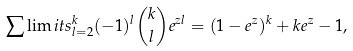<formula> <loc_0><loc_0><loc_500><loc_500>\sum \lim i t s _ { l = 2 } ^ { k } ( - 1 ) ^ { l } \binom { k } { l } e ^ { z l } = ( 1 - e ^ { z } ) ^ { k } + k e ^ { z } - 1 ,</formula> 